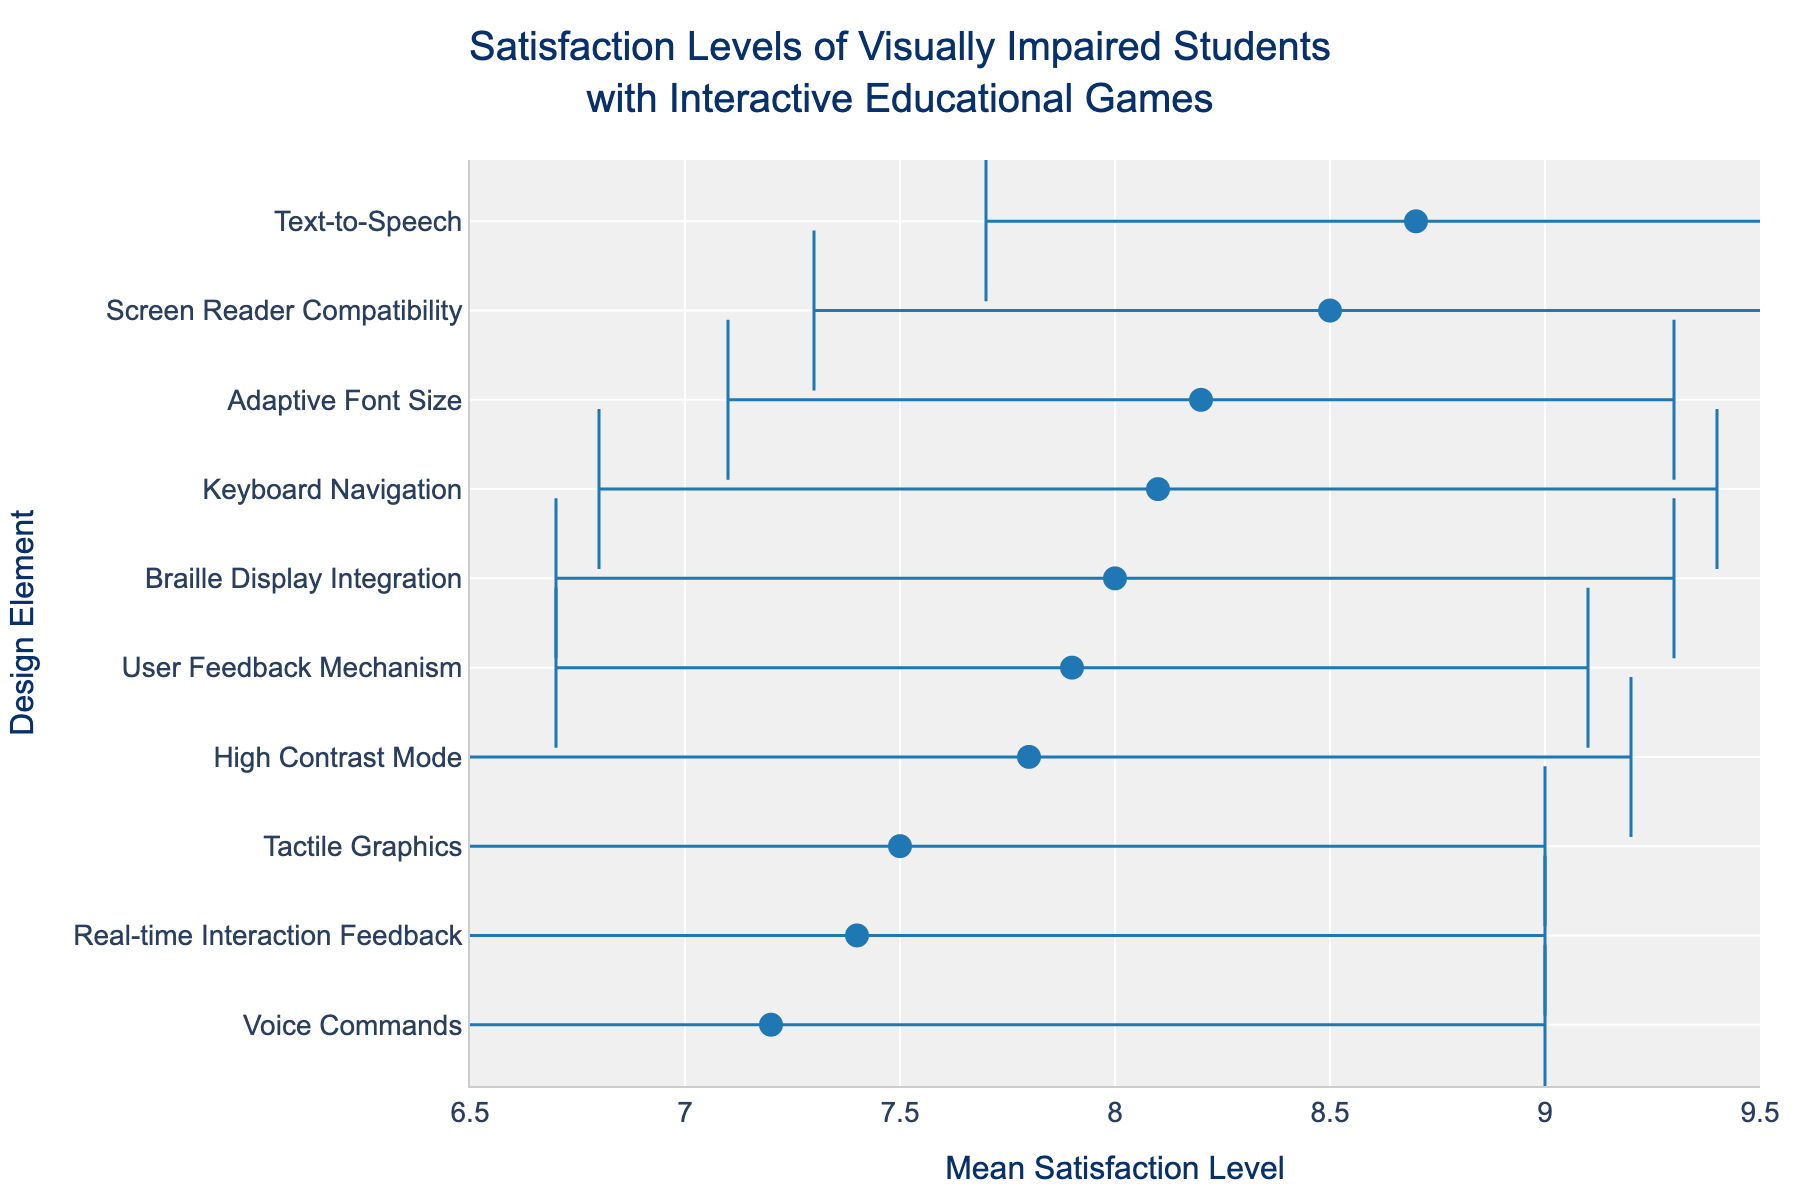what is the title of the figure? The title is mentioned at the top of the figure.
Answer: Satisfaction Levels of Visually Impaired Students with Interactive Educational Games What is the mean satisfaction level for the design element with the lowest satisfaction? The design element with the lowest satisfaction can be found by identifying the element corresponding to the leftmost dot on the x-axis.
Answer: Voice Commands Which design element has the highest mean satisfaction level? The design element with the highest mean satisfaction level can be found by locating the rightmost dot on the x-axis.
Answer: Text-to-Speech What is the range of mean satisfaction levels displayed in the figure? The range is calculated by subtracting the smallest mean satisfaction level from the largest mean satisfaction level. Voice Commands has the lowest mean satisfaction (7.2) and Text-to-Speech has the highest (8.7). So, the range is 8.7 - 7.2.
Answer: 1.5 Which design elements have a mean satisfaction level greater than 8? Identify all design elements with a mean satisfaction level to the right of the x-axis value 8.
Answer: Screen Reader Compatibility, Text-to-Speech, Adaptive Font Size, Keyboard Navigation What is the mean satisfaction level for Braille Display Integration and Adaptive Font Size together? First, find the mean satisfaction levels for Braille Display Integration (8.0) and Adaptive Font Size (8.2). Then, calculate the average of these two values: (8.0 + 8.2) / 2.
Answer: 8.1 Which design element has the largest error bar, indicating the highest variation in satisfaction levels? The design element with the largest error bar can be identified by finding the error bar with the greatest length.
Answer: Voice Commands How many design elements have a standard deviation of less than 1.5? Count the design elements where the error bars represent a standard deviation of less than 1.5.
Answer: Six Is the mean satisfaction level for Real-time Interaction Feedback greater than User Feedback Mechanism? Compare the mean satisfaction levels for Real-time Interaction Feedback (7.4) and User Feedback Mechanism (7.9).
Answer: No Which design element has a mean satisfaction level that is closest to the overall average satisfaction level? First, calculate the overall average by adding the mean satisfaction levels and dividing by the number of design elements. Then, find the design element closest to this value. Sum of means = (8.5 + 7.8 + 8.7 + 7.2 + 8.0 + 7.5 + 8.2 + 8.1 + 7.9 + 7.4) = 79.3 and overall average = 79.3 / 10 = 7.93.
Answer: User Feedback Mechanism 